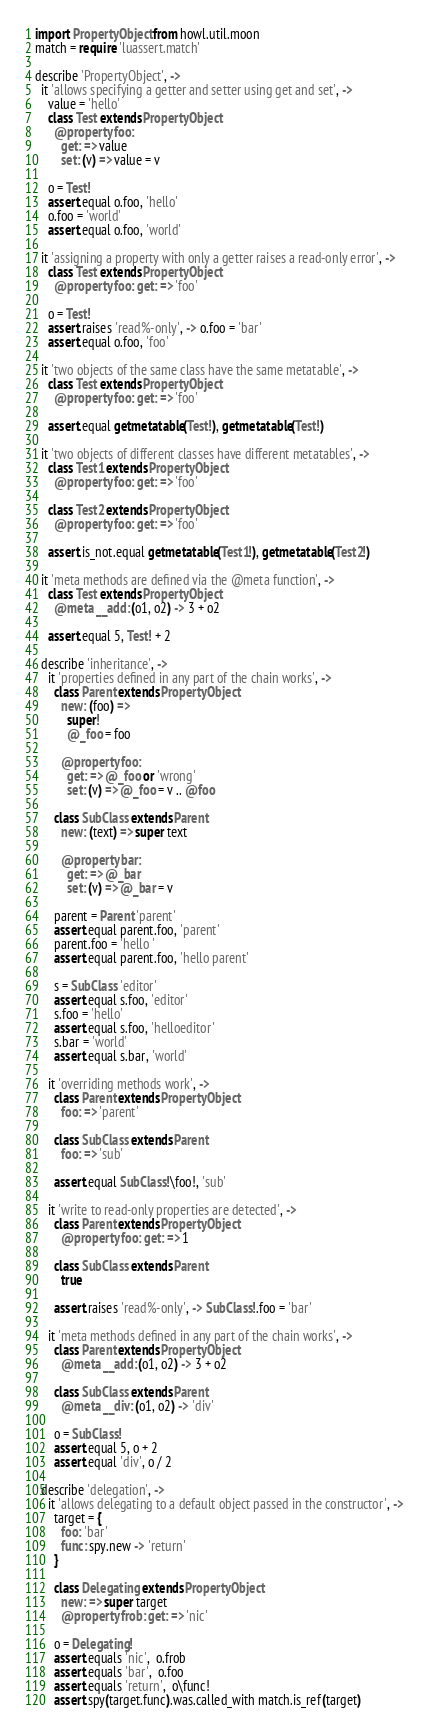<code> <loc_0><loc_0><loc_500><loc_500><_MoonScript_>import PropertyObject from howl.util.moon
match = require 'luassert.match'

describe 'PropertyObject', ->
  it 'allows specifying a getter and setter using get and set', ->
    value = 'hello'
    class Test extends PropertyObject
      @property foo:
        get: => value
        set: (v) => value = v

    o = Test!
    assert.equal o.foo, 'hello'
    o.foo = 'world'
    assert.equal o.foo, 'world'

  it 'assigning a property with only a getter raises a read-only error', ->
    class Test extends PropertyObject
      @property foo: get: => 'foo'

    o = Test!
    assert.raises 'read%-only', -> o.foo = 'bar'
    assert.equal o.foo, 'foo'

  it 'two objects of the same class have the same metatable', ->
    class Test extends PropertyObject
      @property foo: get: => 'foo'

    assert.equal getmetatable(Test!), getmetatable(Test!)

  it 'two objects of different classes have different metatables', ->
    class Test1 extends PropertyObject
      @property foo: get: => 'foo'

    class Test2 extends PropertyObject
      @property foo: get: => 'foo'

    assert.is_not.equal getmetatable(Test1!), getmetatable(Test2!)

  it 'meta methods are defined via the @meta function', ->
    class Test extends PropertyObject
      @meta __add: (o1, o2) -> 3 + o2

    assert.equal 5, Test! + 2

  describe 'inheritance', ->
    it 'properties defined in any part of the chain works', ->
      class Parent extends PropertyObject
        new: (foo) =>
          super!
          @_foo = foo

        @property foo:
          get: => @_foo or 'wrong'
          set: (v) => @_foo = v .. @foo

      class SubClass extends Parent
        new: (text) => super text

        @property bar:
          get: => @_bar
          set: (v) => @_bar = v

      parent = Parent 'parent'
      assert.equal parent.foo, 'parent'
      parent.foo = 'hello '
      assert.equal parent.foo, 'hello parent'

      s = SubClass 'editor'
      assert.equal s.foo, 'editor'
      s.foo = 'hello'
      assert.equal s.foo, 'helloeditor'
      s.bar = 'world'
      assert.equal s.bar, 'world'

    it 'overriding methods work', ->
      class Parent extends PropertyObject
        foo: => 'parent'

      class SubClass extends Parent
        foo: => 'sub'

      assert.equal SubClass!\foo!, 'sub'

    it 'write to read-only properties are detected', ->
      class Parent extends PropertyObject
        @property foo: get: => 1

      class SubClass extends Parent
        true

      assert.raises 'read%-only', -> SubClass!.foo = 'bar'

    it 'meta methods defined in any part of the chain works', ->
      class Parent extends PropertyObject
        @meta __add: (o1, o2) -> 3 + o2

      class SubClass extends Parent
        @meta __div: (o1, o2) -> 'div'

      o = SubClass!
      assert.equal 5, o + 2
      assert.equal 'div', o / 2

  describe 'delegation', ->
    it 'allows delegating to a default object passed in the constructor', ->
      target = {
        foo: 'bar'
        func: spy.new -> 'return'
      }

      class Delegating extends PropertyObject
        new: => super target
        @property frob: get: => 'nic'

      o = Delegating!
      assert.equals 'nic',  o.frob
      assert.equals 'bar',  o.foo
      assert.equals 'return',  o\func!
      assert.spy(target.func).was.called_with match.is_ref(target)
</code> 